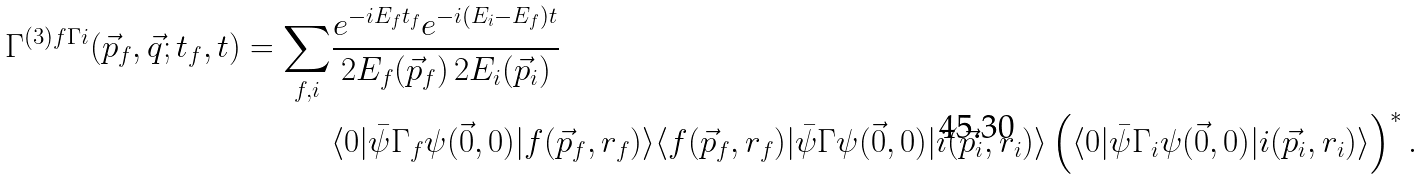<formula> <loc_0><loc_0><loc_500><loc_500>\Gamma ^ { ( 3 ) f \Gamma i } ( \vec { p } _ { f } , \vec { q } ; t _ { f } , t ) = \sum _ { f , i } & \frac { e ^ { - i E _ { f } t _ { f } } e ^ { - i ( E _ { i } - E _ { f } ) t } } { 2 E _ { f } ( \vec { p } _ { f } ) \, 2 E _ { i } ( \vec { p } _ { i } ) } \\ & \langle 0 | \bar { \psi } \Gamma _ { f } \psi ( \vec { 0 } , 0 ) | f ( \vec { p } _ { f } , r _ { f } ) \rangle \langle f ( \vec { p } _ { f } , r _ { f } ) | \bar { \psi } \Gamma \psi ( \vec { 0 } , 0 ) | i ( \vec { p } _ { i } , r _ { i } ) \rangle \left ( \langle 0 | \bar { \psi } \Gamma _ { i } \psi ( \vec { 0 } , 0 ) | i ( \vec { p } _ { i } , r _ { i } ) \rangle \right ) ^ { * } .</formula> 